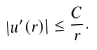Convert formula to latex. <formula><loc_0><loc_0><loc_500><loc_500>| u ^ { \prime } ( r ) | \leq \frac { C } { r } .</formula> 